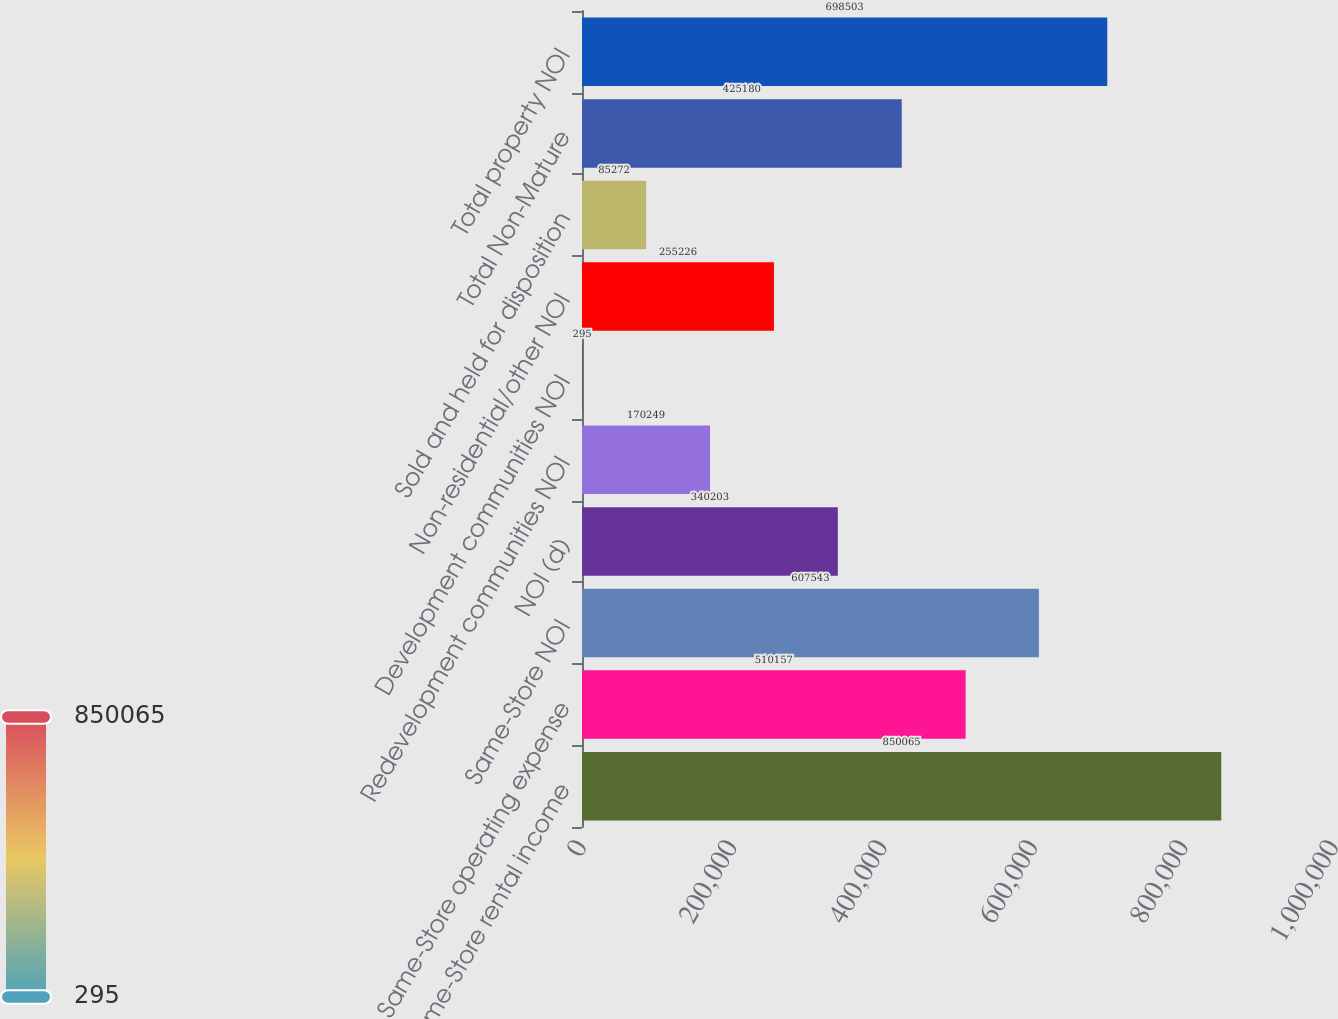Convert chart. <chart><loc_0><loc_0><loc_500><loc_500><bar_chart><fcel>Same-Store rental income<fcel>Same-Store operating expense<fcel>Same-Store NOI<fcel>NOI (d)<fcel>Redevelopment communities NOI<fcel>Development communities NOI<fcel>Non-residential/other NOI<fcel>Sold and held for disposition<fcel>Total Non-Mature<fcel>Total property NOI<nl><fcel>850065<fcel>510157<fcel>607543<fcel>340203<fcel>170249<fcel>295<fcel>255226<fcel>85272<fcel>425180<fcel>698503<nl></chart> 